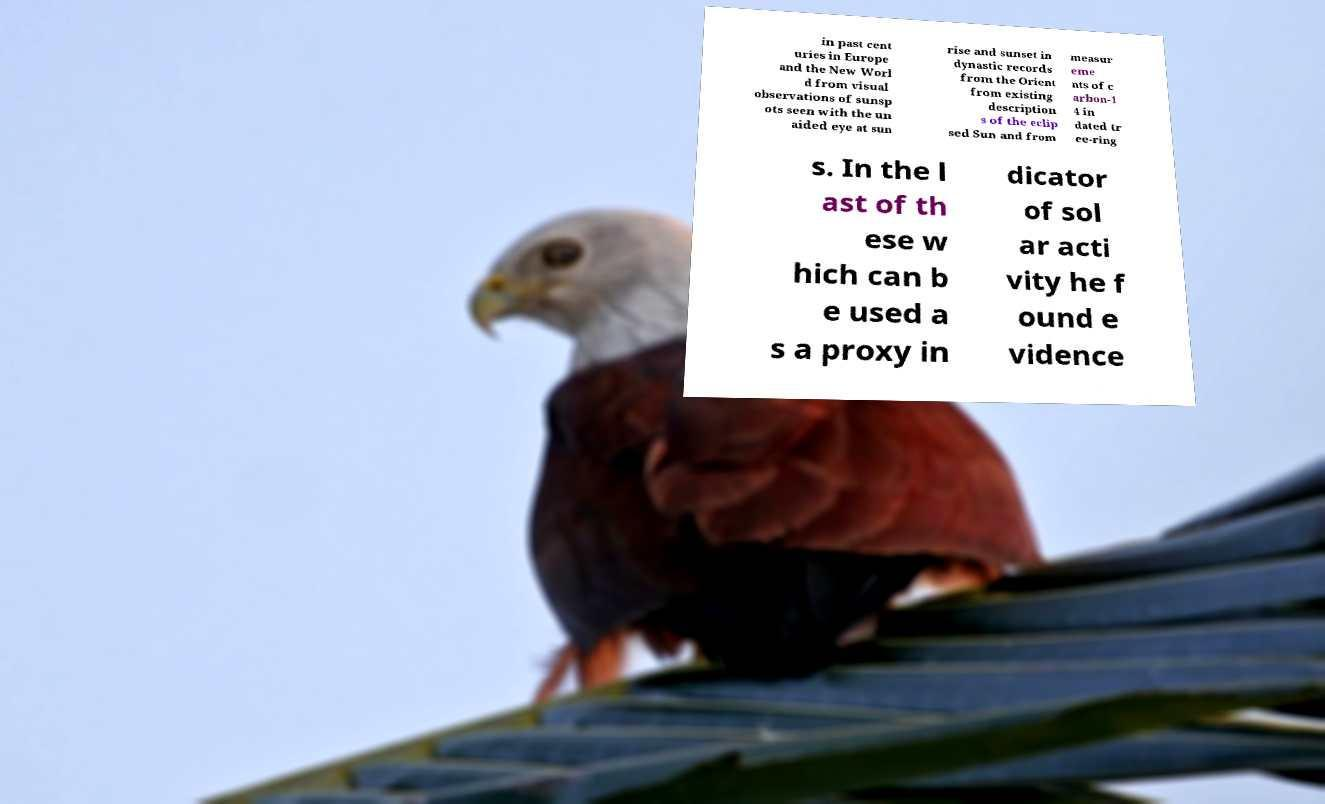What messages or text are displayed in this image? I need them in a readable, typed format. in past cent uries in Europe and the New Worl d from visual observations of sunsp ots seen with the un aided eye at sun rise and sunset in dynastic records from the Orient from existing description s of the eclip sed Sun and from measur eme nts of c arbon-1 4 in dated tr ee-ring s. In the l ast of th ese w hich can b e used a s a proxy in dicator of sol ar acti vity he f ound e vidence 